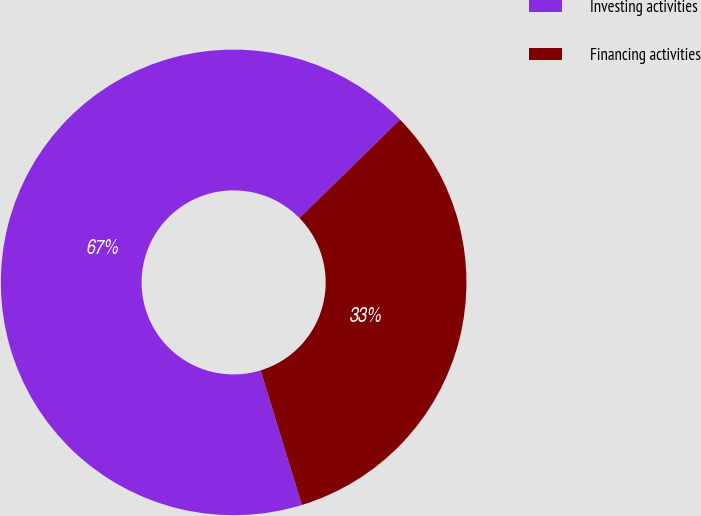Convert chart to OTSL. <chart><loc_0><loc_0><loc_500><loc_500><pie_chart><fcel>Investing activities<fcel>Financing activities<nl><fcel>67.41%<fcel>32.59%<nl></chart> 